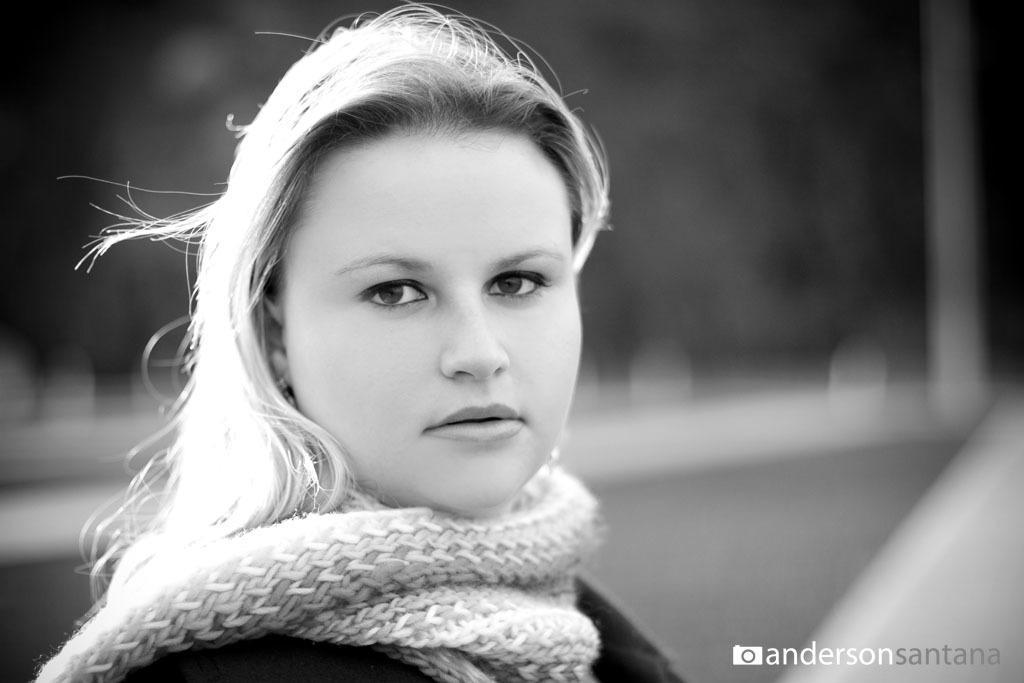In one or two sentences, can you explain what this image depicts? This is an edited picture. In the foreground of the picture there is a woman wearing scarf. The background is blurred. 